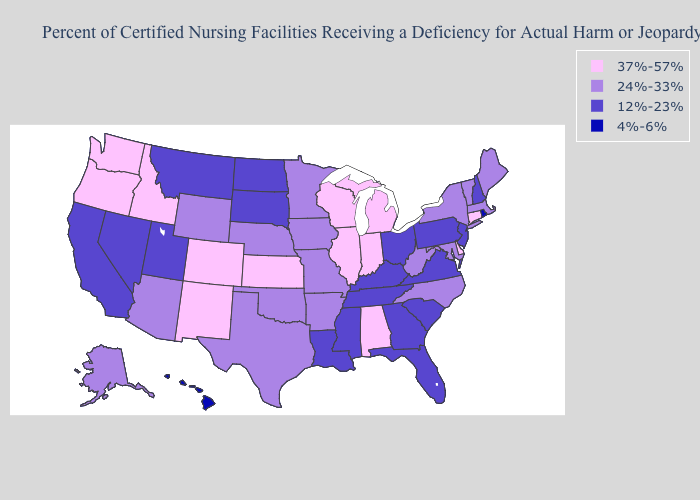What is the value of New Mexico?
Keep it brief. 37%-57%. Does Connecticut have the lowest value in the USA?
Give a very brief answer. No. Name the states that have a value in the range 24%-33%?
Write a very short answer. Alaska, Arizona, Arkansas, Iowa, Maine, Maryland, Massachusetts, Minnesota, Missouri, Nebraska, New York, North Carolina, Oklahoma, Texas, Vermont, West Virginia, Wyoming. Among the states that border Pennsylvania , which have the lowest value?
Write a very short answer. New Jersey, Ohio. What is the highest value in states that border Rhode Island?
Write a very short answer. 37%-57%. What is the lowest value in the South?
Short answer required. 12%-23%. What is the lowest value in the Northeast?
Concise answer only. 4%-6%. Name the states that have a value in the range 37%-57%?
Answer briefly. Alabama, Colorado, Connecticut, Delaware, Idaho, Illinois, Indiana, Kansas, Michigan, New Mexico, Oregon, Washington, Wisconsin. What is the lowest value in the USA?
Give a very brief answer. 4%-6%. Which states have the lowest value in the USA?
Quick response, please. Hawaii, Rhode Island. Name the states that have a value in the range 12%-23%?
Keep it brief. California, Florida, Georgia, Kentucky, Louisiana, Mississippi, Montana, Nevada, New Hampshire, New Jersey, North Dakota, Ohio, Pennsylvania, South Carolina, South Dakota, Tennessee, Utah, Virginia. What is the lowest value in the Northeast?
Write a very short answer. 4%-6%. Which states have the lowest value in the South?
Keep it brief. Florida, Georgia, Kentucky, Louisiana, Mississippi, South Carolina, Tennessee, Virginia. Which states hav the highest value in the Northeast?
Keep it brief. Connecticut. What is the value of Arizona?
Short answer required. 24%-33%. 